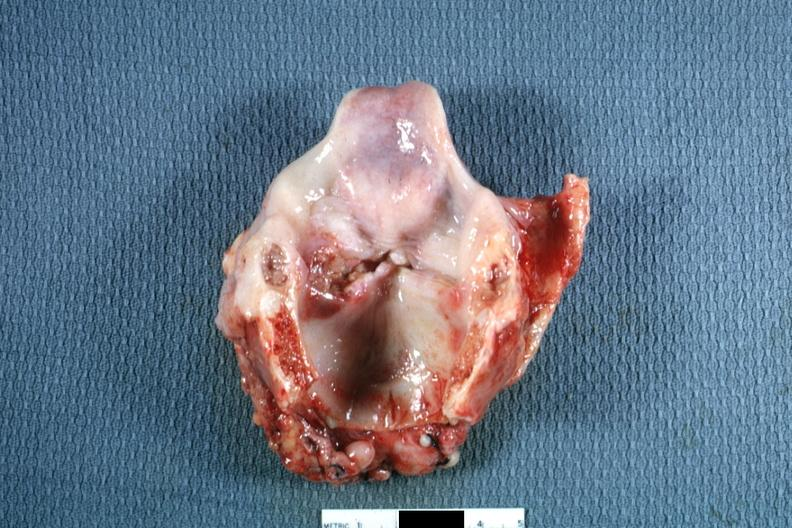how is ulcerative lesion left true cord?
Answer the question using a single word or phrase. Good 